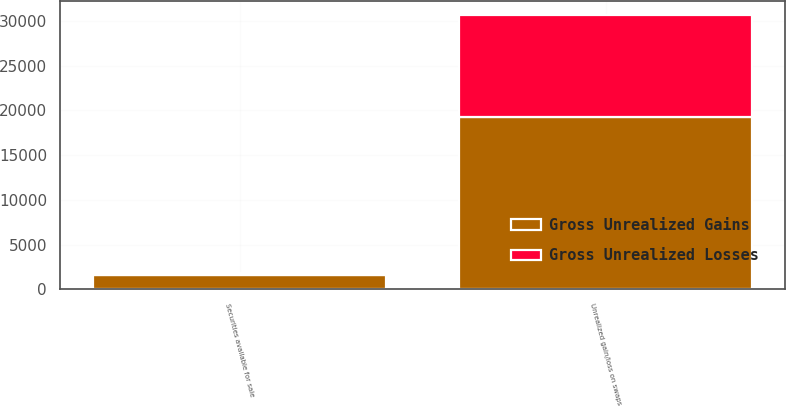Convert chart to OTSL. <chart><loc_0><loc_0><loc_500><loc_500><stacked_bar_chart><ecel><fcel>Securities available for sale<fcel>Unrealized gain/loss on swaps<nl><fcel>Gross Unrealized Gains<fcel>1575<fcel>19252<nl><fcel>Gross Unrealized Losses<fcel>282<fcel>11401<nl></chart> 